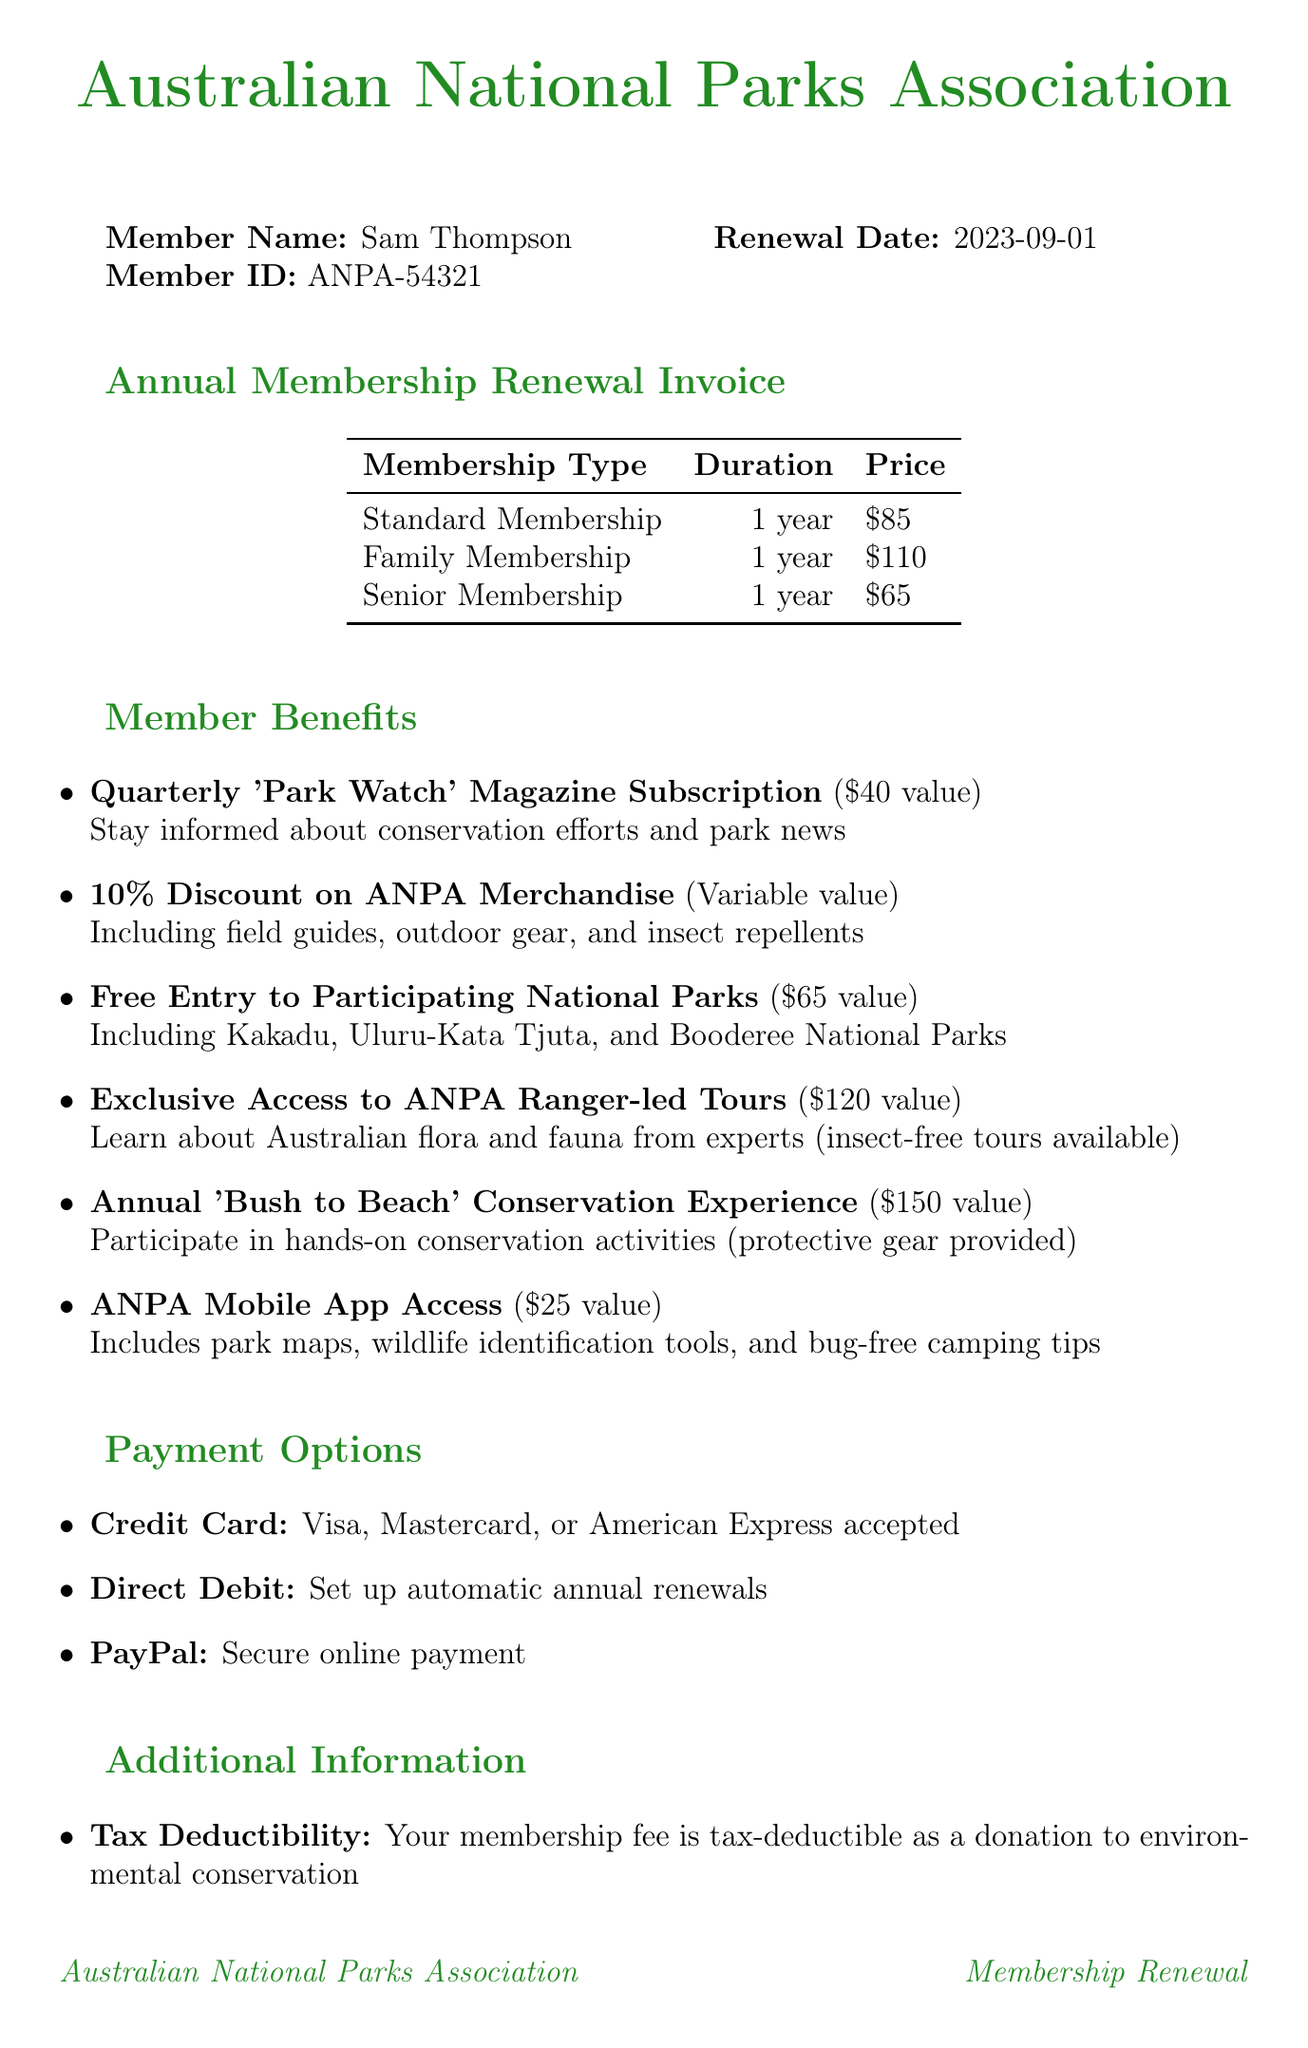What is the member name? The document lists Sam Thompson as the member name.
Answer: Sam Thompson What is the member ID? The member ID for this invoice is provided as ANPA-54321.
Answer: ANPA-54321 When is the renewal date? The renewal date is specified as September 1, 2023.
Answer: 2023-09-01 What is the price of a Standard Membership? The price for a Standard Membership is listed as $85.
Answer: $85 What is the total value of the benefit for the Quarterly 'Park Watch' Magazine Subscription? The document states that the value is $40.
Answer: $40 What membership type offers a discount on merchandise? The document mentions a 10% Discount on ANPA Merchandise as a benefit of membership.
Answer: 10% Discount on ANPA Merchandise What is included in the ANPA Mobile App Access? The access includes park maps, wildlife identification tools, and bug-free camping tips.
Answer: Park maps, wildlife identification tools, and bug-free camping tips Which payment method allows for automatic renewals? The document specifies Direct Debit as the payment method for automatic annual renewals.
Answer: Direct Debit What is the purpose of Tax Deductibility mentioned in the document? The purpose is to state that the membership fee is tax-deductible as a donation to environmental conservation.
Answer: Tax-deductible donation to environmental conservation 